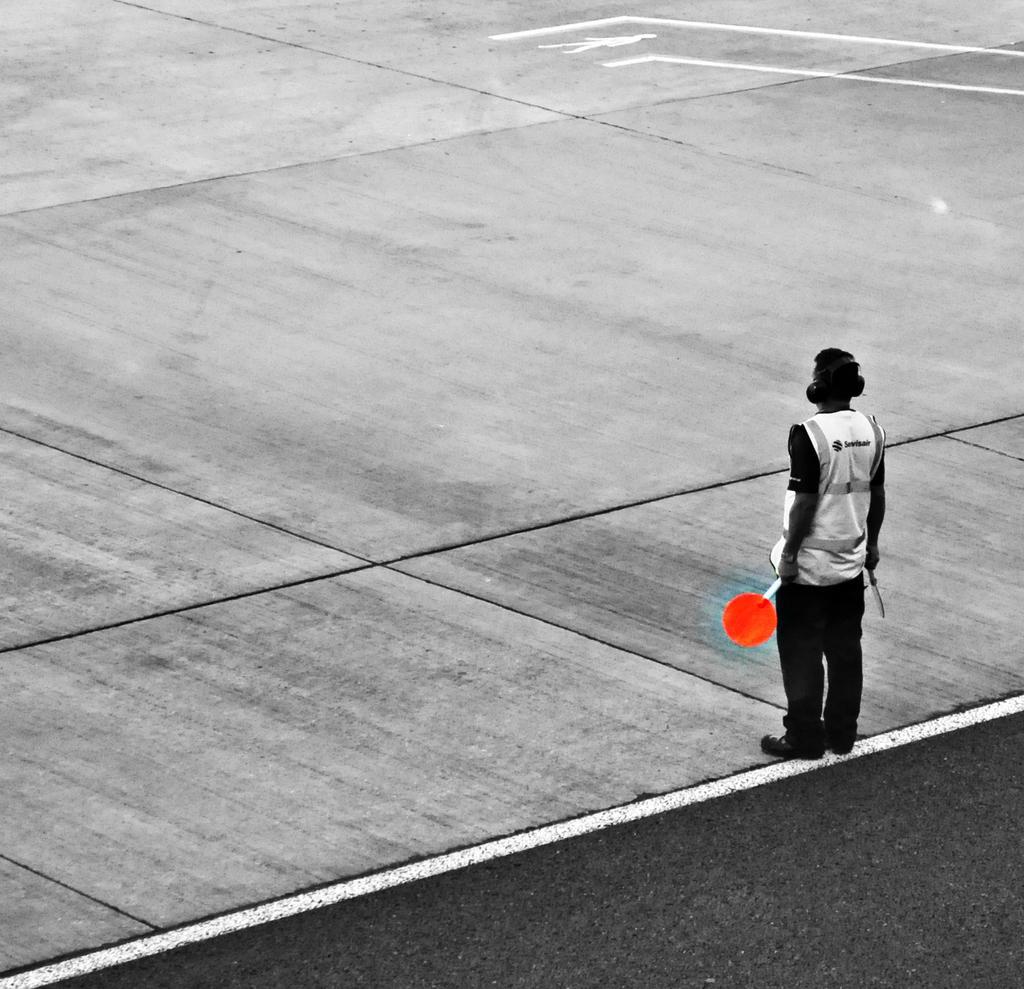Can you describe this image briefly? In the foreground of this image, there is a man is standing by holding two boards in his hands. On the top, there is the road. 